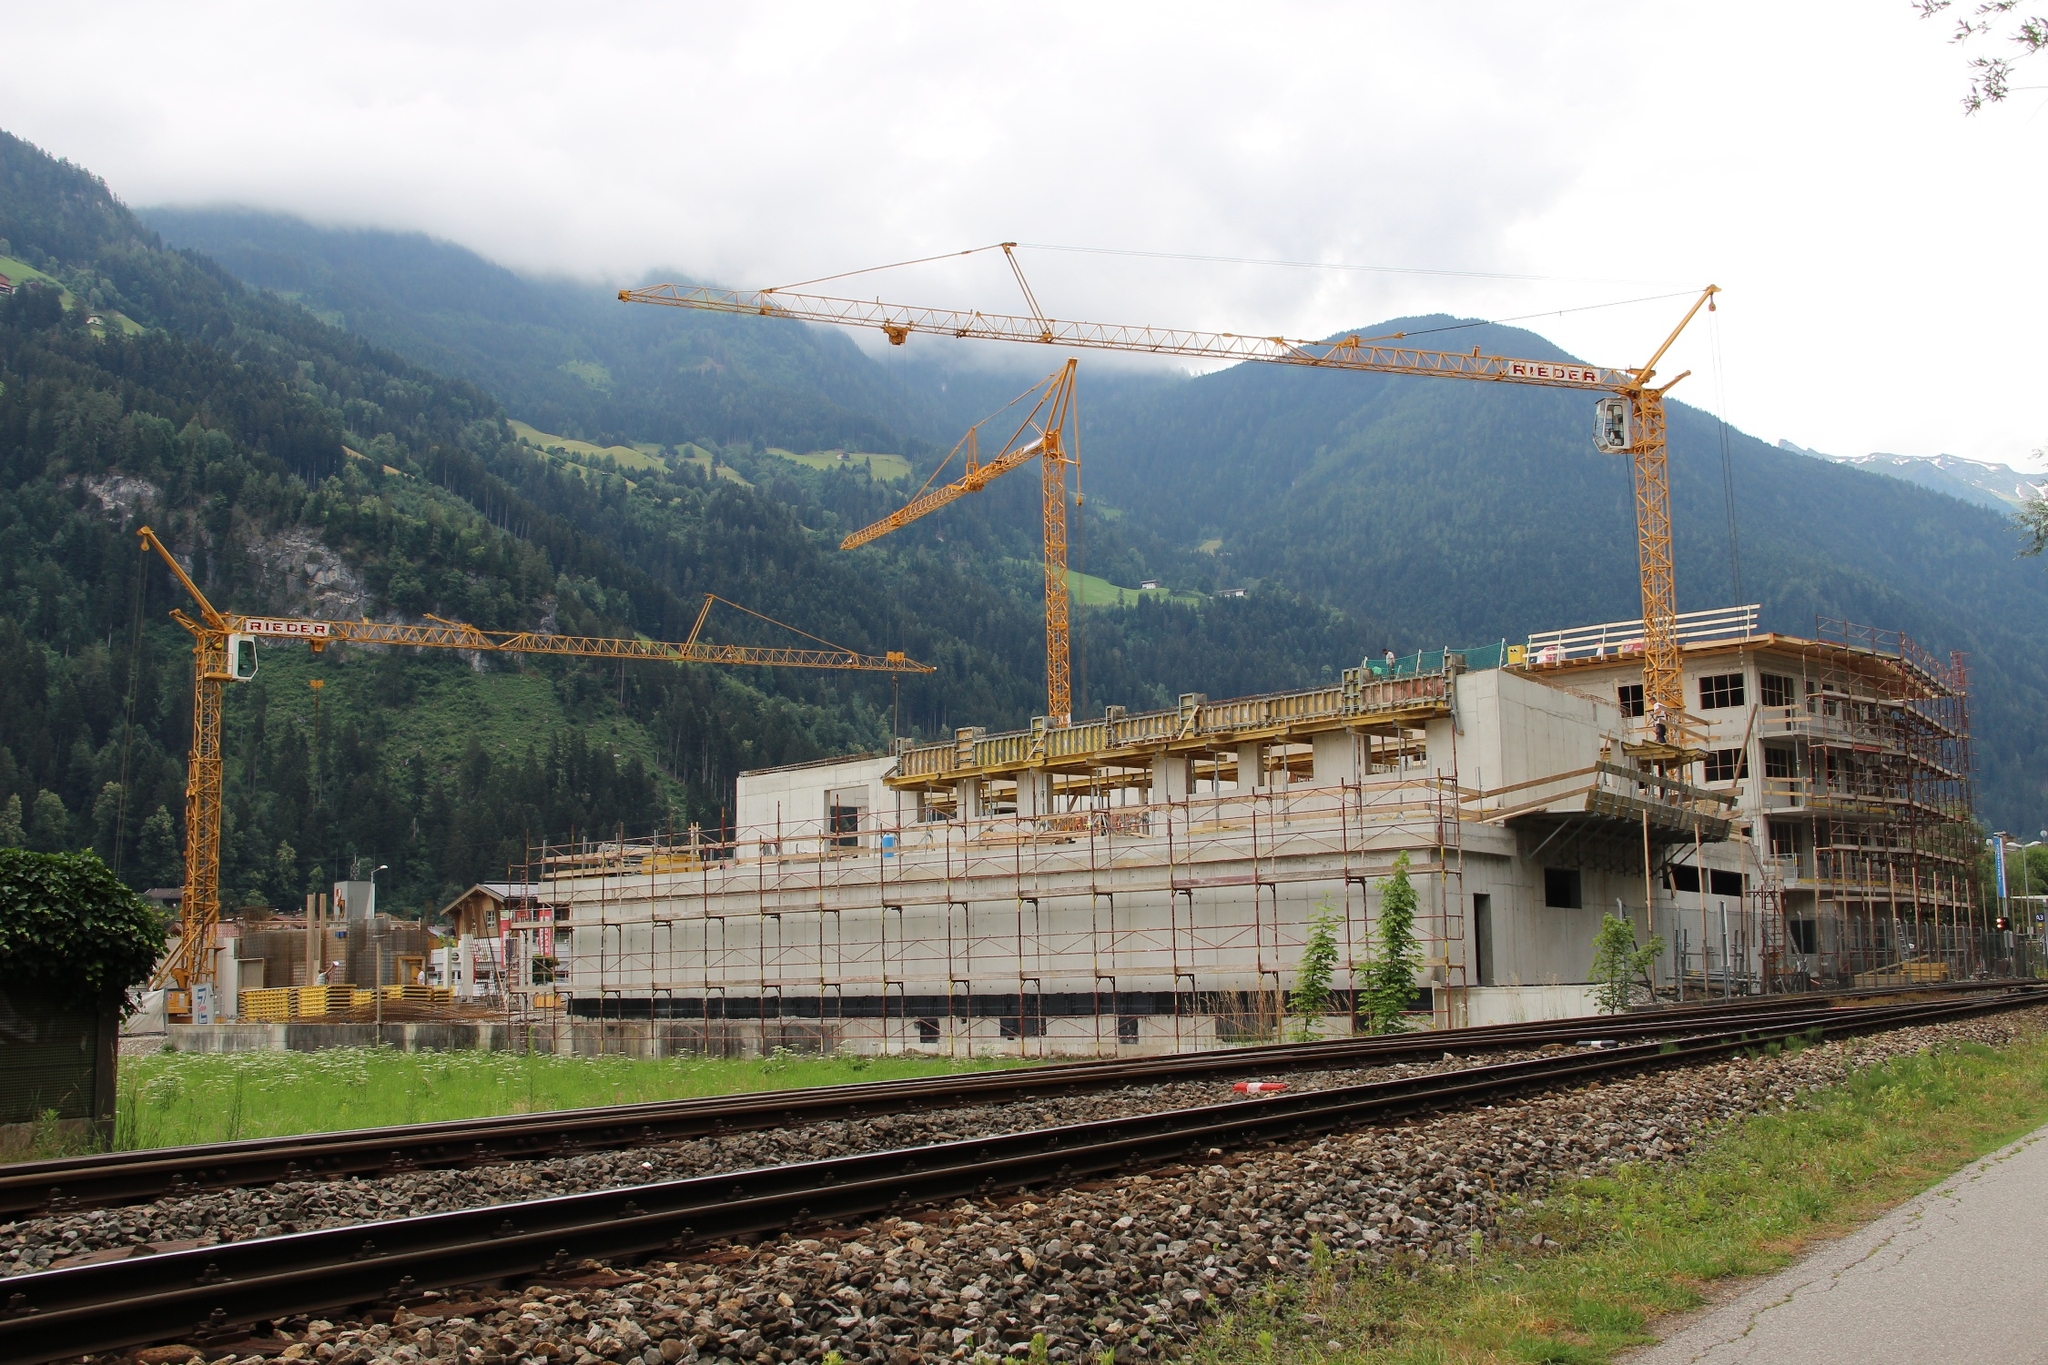Can you create a very detailed and imaginative description of the construction site? In the heart of a secluded mountain range, a bustling construction site comes to life, framed by towering cranes that soar like mechanical giants. The cranes’ long, spindly arms reach skyward, blending seamlessly into the mist-veiled peaks that cradle this scene. Scaffolding clings to the burgeoning building like a metallic exoskeleton, each rod and beam meticulously aligned to support the emerging edifice. Amid this symphony of human ingenuity and machinery, nature stands unwavering, its lush, verdant canopy cascading over rolling hillsides, a silent witness to the unfolding transformation.
The rich, earthy scent of freshly turned soil mingles with the crisp mountain air, as the symphony of whirring gears and hammer blows echo through the valley. Workers, clad in bright safety vests, move like industrious ants, each focused on their task yet contributing to the greater whole. The nearby train track, polished and gleaming, hints at the promise of connectivity and the flow of resources vital to this burgeoning project.
As the scene unfolds, it becomes clear that this is a point of convergence between human ambition and natural grandeur. The distant snow-capped peaks seem almost ethereal, a constant reminder of the beauty and resilience of the natural world. The construction site, while a flurry of activity, is but a fleeting moment in the grand tapestry of these ancient mountains, where every tree and stone holds stories untold. 